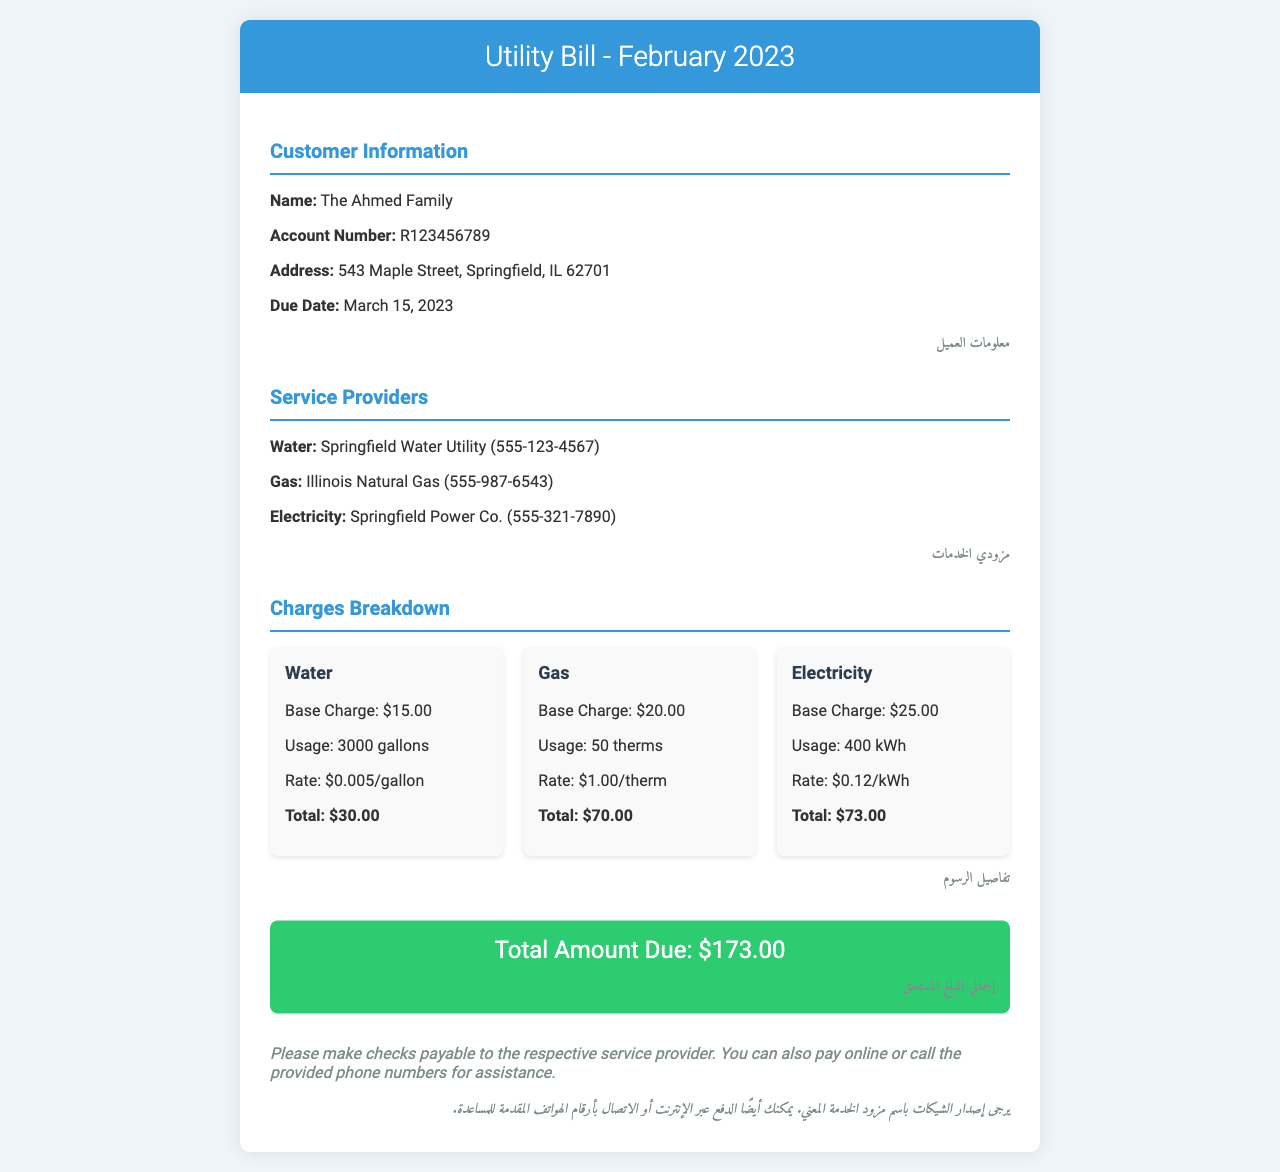What is the due date for the bill? The due date for the bill is mentioned in the customer information section of the document.
Answer: March 15, 2023 How much is the total amount due? The total amount due is found at the end of the charges section, summarizing all charges for the month.
Answer: $173.00 Who is the electricity service provider? The electricity service provider is listed under the service providers section of the document.
Answer: Springfield Power Co What is the base charge for gas? The base charge for gas is detailed in the charges breakdown section.
Answer: $20.00 How much usage was reported for water? The usage for water is specified in the breakdown of the water charges.
Answer: 3000 gallons What is the rate per therm for gas? The rate per therm for gas is included in the description of gas charges.
Answer: $1.00/therm What is the total charge for electricity? The total charge for electricity is calculated and provided in the charges section.
Answer: $73.00 Which language is used for customer information in the document? Arabic is used for including customer information and other sections throughout the invoice.
Answer: Arabic How many different services are listed in the document? The number of different services can be counted from the service providers section.
Answer: Three 